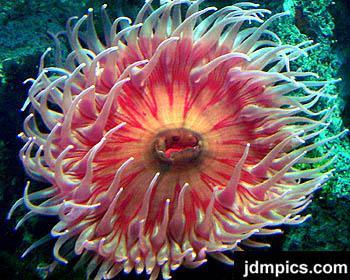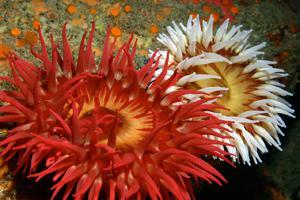The first image is the image on the left, the second image is the image on the right. For the images shown, is this caption "An image includes an anemone with rich orange-red tendrils." true? Answer yes or no. Yes. The first image is the image on the left, the second image is the image on the right. Examine the images to the left and right. Is the description "there are two anemones in one of the images" accurate? Answer yes or no. Yes. 